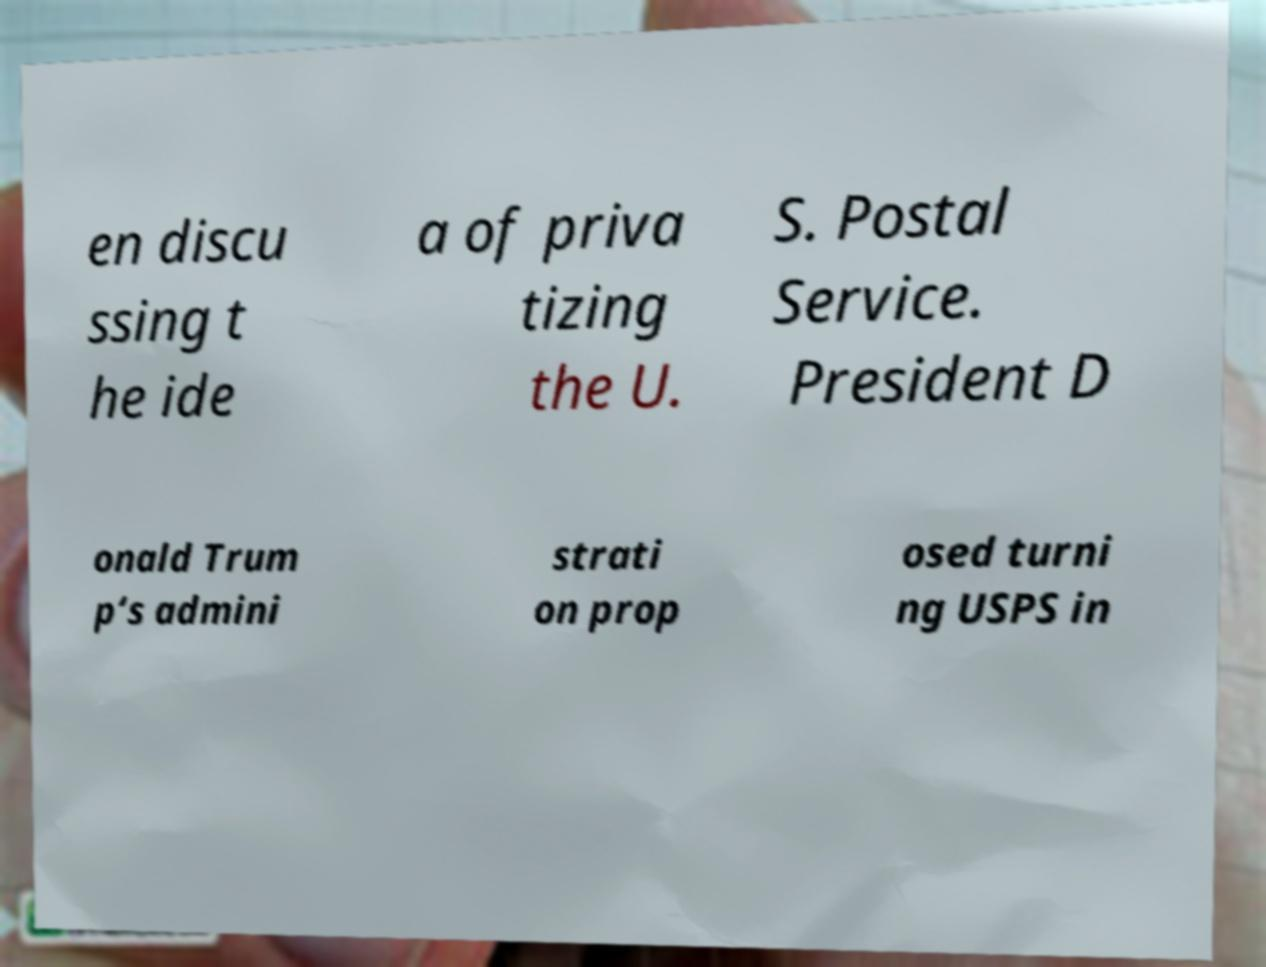For documentation purposes, I need the text within this image transcribed. Could you provide that? en discu ssing t he ide a of priva tizing the U. S. Postal Service. President D onald Trum p‘s admini strati on prop osed turni ng USPS in 